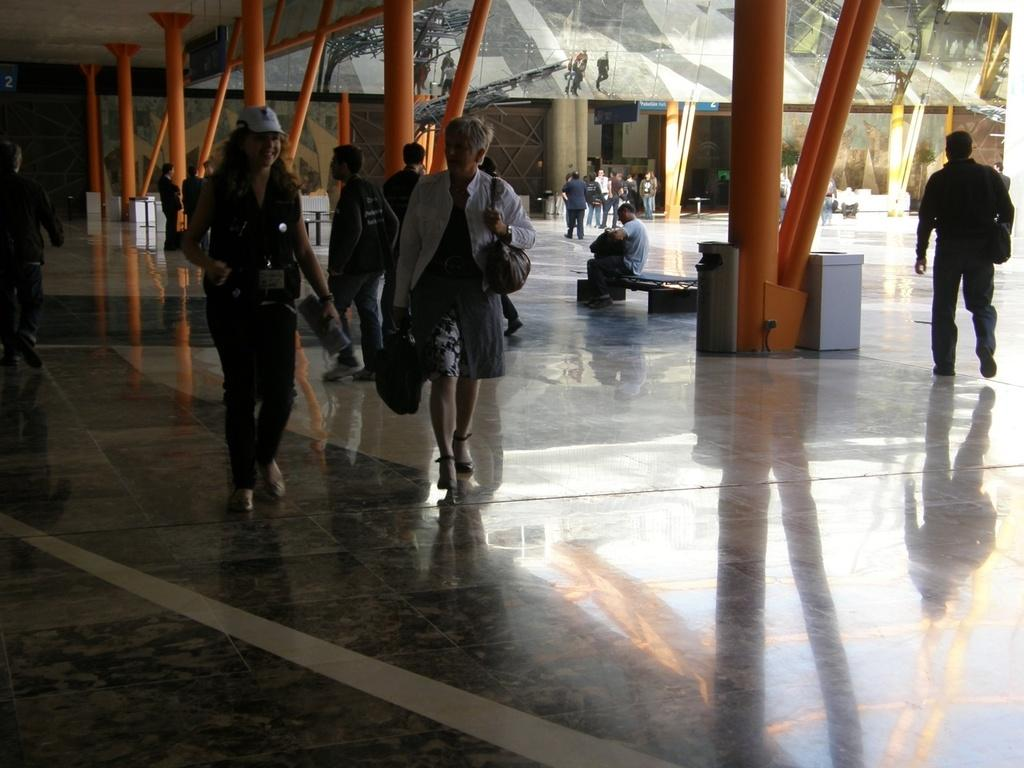What are the people in the image doing? There are people walking in the image. Are there any people sitting in the image? Yes, there are people seated on a bench in the image. What month is depicted in the image? There is no specific month depicted in the image; it only shows people walking and sitting. Is there a church visible in the image? There is no church present in the image. 